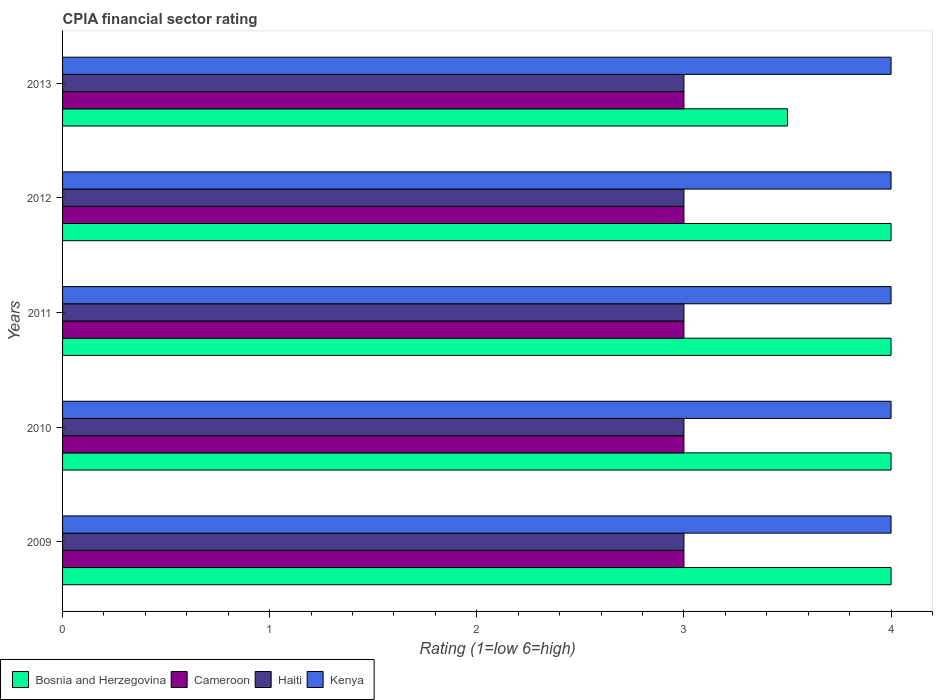How many different coloured bars are there?
Offer a very short reply. 4. How many bars are there on the 2nd tick from the top?
Your answer should be compact. 4. What is the label of the 4th group of bars from the top?
Make the answer very short. 2010. What is the CPIA rating in Cameroon in 2010?
Keep it short and to the point. 3. Across all years, what is the maximum CPIA rating in Bosnia and Herzegovina?
Your response must be concise. 4. Across all years, what is the minimum CPIA rating in Kenya?
Make the answer very short. 4. In which year was the CPIA rating in Bosnia and Herzegovina maximum?
Give a very brief answer. 2009. What is the total CPIA rating in Cameroon in the graph?
Provide a short and direct response. 15. What is the difference between the CPIA rating in Bosnia and Herzegovina in 2010 and that in 2011?
Offer a very short reply. 0. What is the average CPIA rating in Haiti per year?
Make the answer very short. 3. Is the CPIA rating in Kenya in 2010 less than that in 2012?
Your answer should be very brief. No. What is the difference between the highest and the lowest CPIA rating in Kenya?
Offer a terse response. 0. In how many years, is the CPIA rating in Kenya greater than the average CPIA rating in Kenya taken over all years?
Provide a succinct answer. 0. Is the sum of the CPIA rating in Haiti in 2011 and 2013 greater than the maximum CPIA rating in Kenya across all years?
Keep it short and to the point. Yes. Is it the case that in every year, the sum of the CPIA rating in Cameroon and CPIA rating in Kenya is greater than the sum of CPIA rating in Haiti and CPIA rating in Bosnia and Herzegovina?
Provide a short and direct response. Yes. What does the 4th bar from the top in 2013 represents?
Offer a terse response. Bosnia and Herzegovina. What does the 4th bar from the bottom in 2010 represents?
Offer a very short reply. Kenya. How many bars are there?
Keep it short and to the point. 20. Are the values on the major ticks of X-axis written in scientific E-notation?
Your response must be concise. No. How are the legend labels stacked?
Your answer should be very brief. Horizontal. What is the title of the graph?
Give a very brief answer. CPIA financial sector rating. What is the label or title of the X-axis?
Make the answer very short. Rating (1=low 6=high). What is the label or title of the Y-axis?
Your answer should be very brief. Years. What is the Rating (1=low 6=high) in Bosnia and Herzegovina in 2009?
Your response must be concise. 4. What is the Rating (1=low 6=high) in Cameroon in 2009?
Provide a succinct answer. 3. What is the Rating (1=low 6=high) in Haiti in 2009?
Give a very brief answer. 3. What is the Rating (1=low 6=high) of Bosnia and Herzegovina in 2010?
Give a very brief answer. 4. What is the Rating (1=low 6=high) of Cameroon in 2010?
Provide a short and direct response. 3. What is the Rating (1=low 6=high) of Cameroon in 2011?
Ensure brevity in your answer.  3. What is the Rating (1=low 6=high) of Haiti in 2011?
Provide a succinct answer. 3. What is the Rating (1=low 6=high) of Bosnia and Herzegovina in 2012?
Offer a very short reply. 4. What is the Rating (1=low 6=high) of Cameroon in 2012?
Your answer should be very brief. 3. What is the Rating (1=low 6=high) of Haiti in 2012?
Offer a terse response. 3. What is the Rating (1=low 6=high) in Kenya in 2012?
Offer a very short reply. 4. What is the Rating (1=low 6=high) of Haiti in 2013?
Provide a succinct answer. 3. What is the Rating (1=low 6=high) of Kenya in 2013?
Keep it short and to the point. 4. Across all years, what is the maximum Rating (1=low 6=high) in Bosnia and Herzegovina?
Your response must be concise. 4. Across all years, what is the maximum Rating (1=low 6=high) of Cameroon?
Your answer should be compact. 3. Across all years, what is the maximum Rating (1=low 6=high) in Kenya?
Provide a short and direct response. 4. Across all years, what is the minimum Rating (1=low 6=high) of Bosnia and Herzegovina?
Provide a succinct answer. 3.5. Across all years, what is the minimum Rating (1=low 6=high) of Cameroon?
Your answer should be very brief. 3. What is the total Rating (1=low 6=high) of Bosnia and Herzegovina in the graph?
Your response must be concise. 19.5. What is the total Rating (1=low 6=high) of Cameroon in the graph?
Provide a succinct answer. 15. What is the total Rating (1=low 6=high) in Kenya in the graph?
Your answer should be very brief. 20. What is the difference between the Rating (1=low 6=high) in Bosnia and Herzegovina in 2009 and that in 2010?
Your answer should be compact. 0. What is the difference between the Rating (1=low 6=high) in Haiti in 2009 and that in 2011?
Your answer should be very brief. 0. What is the difference between the Rating (1=low 6=high) of Kenya in 2009 and that in 2011?
Keep it short and to the point. 0. What is the difference between the Rating (1=low 6=high) of Bosnia and Herzegovina in 2009 and that in 2012?
Give a very brief answer. 0. What is the difference between the Rating (1=low 6=high) of Haiti in 2009 and that in 2012?
Offer a very short reply. 0. What is the difference between the Rating (1=low 6=high) of Kenya in 2009 and that in 2012?
Provide a short and direct response. 0. What is the difference between the Rating (1=low 6=high) of Bosnia and Herzegovina in 2009 and that in 2013?
Offer a terse response. 0.5. What is the difference between the Rating (1=low 6=high) of Bosnia and Herzegovina in 2010 and that in 2011?
Offer a very short reply. 0. What is the difference between the Rating (1=low 6=high) of Haiti in 2010 and that in 2011?
Offer a very short reply. 0. What is the difference between the Rating (1=low 6=high) in Haiti in 2010 and that in 2012?
Your response must be concise. 0. What is the difference between the Rating (1=low 6=high) in Kenya in 2010 and that in 2012?
Offer a very short reply. 0. What is the difference between the Rating (1=low 6=high) of Bosnia and Herzegovina in 2010 and that in 2013?
Keep it short and to the point. 0.5. What is the difference between the Rating (1=low 6=high) in Cameroon in 2010 and that in 2013?
Give a very brief answer. 0. What is the difference between the Rating (1=low 6=high) in Cameroon in 2011 and that in 2012?
Make the answer very short. 0. What is the difference between the Rating (1=low 6=high) of Bosnia and Herzegovina in 2011 and that in 2013?
Keep it short and to the point. 0.5. What is the difference between the Rating (1=low 6=high) in Cameroon in 2011 and that in 2013?
Provide a succinct answer. 0. What is the difference between the Rating (1=low 6=high) in Kenya in 2011 and that in 2013?
Make the answer very short. 0. What is the difference between the Rating (1=low 6=high) of Bosnia and Herzegovina in 2012 and that in 2013?
Offer a terse response. 0.5. What is the difference between the Rating (1=low 6=high) of Cameroon in 2012 and that in 2013?
Offer a very short reply. 0. What is the difference between the Rating (1=low 6=high) of Kenya in 2012 and that in 2013?
Offer a terse response. 0. What is the difference between the Rating (1=low 6=high) of Bosnia and Herzegovina in 2009 and the Rating (1=low 6=high) of Cameroon in 2010?
Your response must be concise. 1. What is the difference between the Rating (1=low 6=high) of Bosnia and Herzegovina in 2009 and the Rating (1=low 6=high) of Kenya in 2010?
Your answer should be very brief. 0. What is the difference between the Rating (1=low 6=high) in Cameroon in 2009 and the Rating (1=low 6=high) in Haiti in 2010?
Give a very brief answer. 0. What is the difference between the Rating (1=low 6=high) of Cameroon in 2009 and the Rating (1=low 6=high) of Kenya in 2010?
Provide a succinct answer. -1. What is the difference between the Rating (1=low 6=high) of Haiti in 2009 and the Rating (1=low 6=high) of Kenya in 2010?
Offer a very short reply. -1. What is the difference between the Rating (1=low 6=high) in Bosnia and Herzegovina in 2009 and the Rating (1=low 6=high) in Haiti in 2011?
Your response must be concise. 1. What is the difference between the Rating (1=low 6=high) in Cameroon in 2009 and the Rating (1=low 6=high) in Haiti in 2011?
Your response must be concise. 0. What is the difference between the Rating (1=low 6=high) of Haiti in 2009 and the Rating (1=low 6=high) of Kenya in 2011?
Offer a terse response. -1. What is the difference between the Rating (1=low 6=high) of Cameroon in 2009 and the Rating (1=low 6=high) of Haiti in 2012?
Your answer should be compact. 0. What is the difference between the Rating (1=low 6=high) of Bosnia and Herzegovina in 2009 and the Rating (1=low 6=high) of Cameroon in 2013?
Provide a succinct answer. 1. What is the difference between the Rating (1=low 6=high) of Bosnia and Herzegovina in 2009 and the Rating (1=low 6=high) of Kenya in 2013?
Give a very brief answer. 0. What is the difference between the Rating (1=low 6=high) in Cameroon in 2009 and the Rating (1=low 6=high) in Haiti in 2013?
Your answer should be compact. 0. What is the difference between the Rating (1=low 6=high) in Cameroon in 2009 and the Rating (1=low 6=high) in Kenya in 2013?
Your answer should be very brief. -1. What is the difference between the Rating (1=low 6=high) of Bosnia and Herzegovina in 2010 and the Rating (1=low 6=high) of Haiti in 2011?
Your answer should be very brief. 1. What is the difference between the Rating (1=low 6=high) in Cameroon in 2010 and the Rating (1=low 6=high) in Haiti in 2011?
Provide a succinct answer. 0. What is the difference between the Rating (1=low 6=high) of Haiti in 2010 and the Rating (1=low 6=high) of Kenya in 2011?
Offer a terse response. -1. What is the difference between the Rating (1=low 6=high) of Bosnia and Herzegovina in 2010 and the Rating (1=low 6=high) of Haiti in 2012?
Provide a short and direct response. 1. What is the difference between the Rating (1=low 6=high) in Bosnia and Herzegovina in 2010 and the Rating (1=low 6=high) in Kenya in 2012?
Offer a terse response. 0. What is the difference between the Rating (1=low 6=high) of Cameroon in 2010 and the Rating (1=low 6=high) of Haiti in 2012?
Your answer should be very brief. 0. What is the difference between the Rating (1=low 6=high) in Cameroon in 2010 and the Rating (1=low 6=high) in Kenya in 2012?
Give a very brief answer. -1. What is the difference between the Rating (1=low 6=high) of Bosnia and Herzegovina in 2010 and the Rating (1=low 6=high) of Cameroon in 2013?
Give a very brief answer. 1. What is the difference between the Rating (1=low 6=high) of Bosnia and Herzegovina in 2010 and the Rating (1=low 6=high) of Haiti in 2013?
Ensure brevity in your answer.  1. What is the difference between the Rating (1=low 6=high) in Haiti in 2010 and the Rating (1=low 6=high) in Kenya in 2013?
Offer a very short reply. -1. What is the difference between the Rating (1=low 6=high) in Bosnia and Herzegovina in 2011 and the Rating (1=low 6=high) in Cameroon in 2012?
Provide a short and direct response. 1. What is the difference between the Rating (1=low 6=high) of Cameroon in 2011 and the Rating (1=low 6=high) of Haiti in 2012?
Your answer should be very brief. 0. What is the difference between the Rating (1=low 6=high) in Bosnia and Herzegovina in 2011 and the Rating (1=low 6=high) in Cameroon in 2013?
Give a very brief answer. 1. What is the difference between the Rating (1=low 6=high) of Bosnia and Herzegovina in 2011 and the Rating (1=low 6=high) of Haiti in 2013?
Offer a terse response. 1. What is the difference between the Rating (1=low 6=high) in Bosnia and Herzegovina in 2011 and the Rating (1=low 6=high) in Kenya in 2013?
Provide a succinct answer. 0. What is the difference between the Rating (1=low 6=high) in Bosnia and Herzegovina in 2012 and the Rating (1=low 6=high) in Haiti in 2013?
Make the answer very short. 1. What is the difference between the Rating (1=low 6=high) of Cameroon in 2012 and the Rating (1=low 6=high) of Haiti in 2013?
Offer a very short reply. 0. What is the average Rating (1=low 6=high) in Bosnia and Herzegovina per year?
Your answer should be compact. 3.9. What is the average Rating (1=low 6=high) of Haiti per year?
Give a very brief answer. 3. What is the average Rating (1=low 6=high) of Kenya per year?
Give a very brief answer. 4. In the year 2009, what is the difference between the Rating (1=low 6=high) in Bosnia and Herzegovina and Rating (1=low 6=high) in Cameroon?
Ensure brevity in your answer.  1. In the year 2009, what is the difference between the Rating (1=low 6=high) in Bosnia and Herzegovina and Rating (1=low 6=high) in Haiti?
Your answer should be very brief. 1. In the year 2009, what is the difference between the Rating (1=low 6=high) in Cameroon and Rating (1=low 6=high) in Haiti?
Provide a short and direct response. 0. In the year 2009, what is the difference between the Rating (1=low 6=high) of Cameroon and Rating (1=low 6=high) of Kenya?
Your response must be concise. -1. In the year 2009, what is the difference between the Rating (1=low 6=high) of Haiti and Rating (1=low 6=high) of Kenya?
Keep it short and to the point. -1. In the year 2010, what is the difference between the Rating (1=low 6=high) in Cameroon and Rating (1=low 6=high) in Haiti?
Provide a short and direct response. 0. In the year 2010, what is the difference between the Rating (1=low 6=high) in Cameroon and Rating (1=low 6=high) in Kenya?
Offer a very short reply. -1. In the year 2011, what is the difference between the Rating (1=low 6=high) of Bosnia and Herzegovina and Rating (1=low 6=high) of Cameroon?
Offer a very short reply. 1. In the year 2011, what is the difference between the Rating (1=low 6=high) in Cameroon and Rating (1=low 6=high) in Haiti?
Offer a very short reply. 0. In the year 2011, what is the difference between the Rating (1=low 6=high) of Cameroon and Rating (1=low 6=high) of Kenya?
Provide a succinct answer. -1. In the year 2011, what is the difference between the Rating (1=low 6=high) in Haiti and Rating (1=low 6=high) in Kenya?
Your answer should be very brief. -1. In the year 2012, what is the difference between the Rating (1=low 6=high) in Bosnia and Herzegovina and Rating (1=low 6=high) in Cameroon?
Make the answer very short. 1. In the year 2012, what is the difference between the Rating (1=low 6=high) of Bosnia and Herzegovina and Rating (1=low 6=high) of Haiti?
Your response must be concise. 1. In the year 2012, what is the difference between the Rating (1=low 6=high) in Cameroon and Rating (1=low 6=high) in Haiti?
Your answer should be compact. 0. In the year 2012, what is the difference between the Rating (1=low 6=high) of Haiti and Rating (1=low 6=high) of Kenya?
Offer a terse response. -1. What is the ratio of the Rating (1=low 6=high) in Bosnia and Herzegovina in 2009 to that in 2010?
Give a very brief answer. 1. What is the ratio of the Rating (1=low 6=high) in Haiti in 2009 to that in 2010?
Keep it short and to the point. 1. What is the ratio of the Rating (1=low 6=high) of Kenya in 2009 to that in 2010?
Offer a terse response. 1. What is the ratio of the Rating (1=low 6=high) in Bosnia and Herzegovina in 2009 to that in 2011?
Your answer should be compact. 1. What is the ratio of the Rating (1=low 6=high) of Cameroon in 2009 to that in 2012?
Your answer should be very brief. 1. What is the ratio of the Rating (1=low 6=high) in Kenya in 2009 to that in 2012?
Ensure brevity in your answer.  1. What is the ratio of the Rating (1=low 6=high) of Kenya in 2009 to that in 2013?
Offer a terse response. 1. What is the ratio of the Rating (1=low 6=high) of Bosnia and Herzegovina in 2010 to that in 2011?
Ensure brevity in your answer.  1. What is the ratio of the Rating (1=low 6=high) in Bosnia and Herzegovina in 2010 to that in 2012?
Ensure brevity in your answer.  1. What is the ratio of the Rating (1=low 6=high) in Cameroon in 2010 to that in 2012?
Your answer should be compact. 1. What is the ratio of the Rating (1=low 6=high) of Cameroon in 2010 to that in 2013?
Your response must be concise. 1. What is the ratio of the Rating (1=low 6=high) in Bosnia and Herzegovina in 2011 to that in 2012?
Provide a short and direct response. 1. What is the ratio of the Rating (1=low 6=high) of Cameroon in 2011 to that in 2012?
Your answer should be very brief. 1. What is the ratio of the Rating (1=low 6=high) of Kenya in 2011 to that in 2012?
Ensure brevity in your answer.  1. What is the ratio of the Rating (1=low 6=high) in Bosnia and Herzegovina in 2011 to that in 2013?
Provide a succinct answer. 1.14. What is the ratio of the Rating (1=low 6=high) of Kenya in 2011 to that in 2013?
Your answer should be very brief. 1. What is the ratio of the Rating (1=low 6=high) of Cameroon in 2012 to that in 2013?
Give a very brief answer. 1. What is the difference between the highest and the second highest Rating (1=low 6=high) in Cameroon?
Offer a terse response. 0. What is the difference between the highest and the second highest Rating (1=low 6=high) of Haiti?
Offer a terse response. 0. What is the difference between the highest and the lowest Rating (1=low 6=high) in Bosnia and Herzegovina?
Your response must be concise. 0.5. What is the difference between the highest and the lowest Rating (1=low 6=high) of Cameroon?
Keep it short and to the point. 0. 